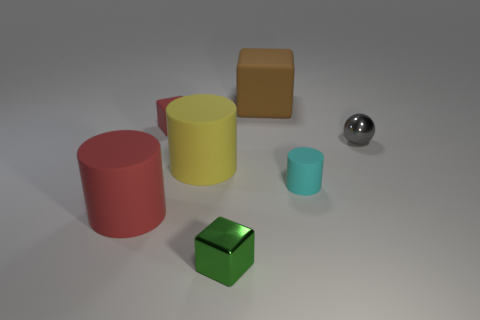Can you tell me about the lighting and shadows in this image? Certainly, you can see soft shadows cast by each object, suggesting a diffused light source above and to the right. The shadows help provide a sense of depth and the position of the objects relative to the light. Which object seems to reflect the most light? The sphere reflects the most light due to its shiny, reflective surface, which indicates it may be made of a material like polished metal. 